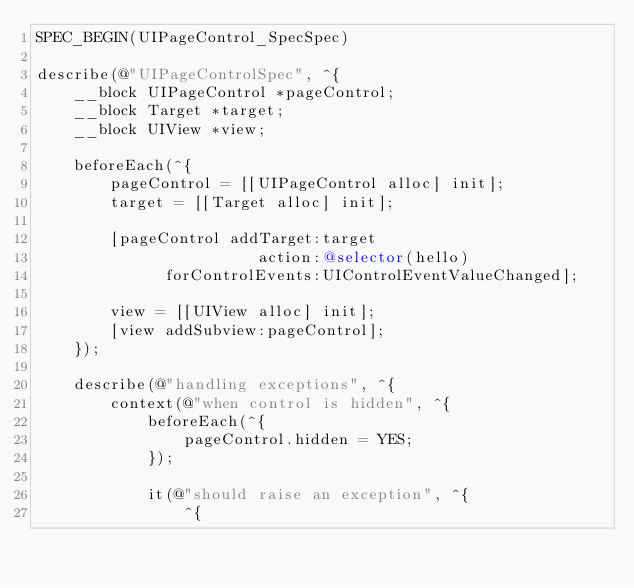<code> <loc_0><loc_0><loc_500><loc_500><_ObjectiveC_>SPEC_BEGIN(UIPageControl_SpecSpec)

describe(@"UIPageControlSpec", ^{
    __block UIPageControl *pageControl;
    __block Target *target;
    __block UIView *view;

    beforeEach(^{
        pageControl = [[UIPageControl alloc] init];
        target = [[Target alloc] init];
        
        [pageControl addTarget:target
                        action:@selector(hello)
              forControlEvents:UIControlEventValueChanged];
        
        view = [[UIView alloc] init];
        [view addSubview:pageControl];
    });

    describe(@"handling exceptions", ^{
        context(@"when control is hidden", ^{
            beforeEach(^{
                pageControl.hidden = YES;
            });
            
            it(@"should raise an exception", ^{
                ^{</code> 